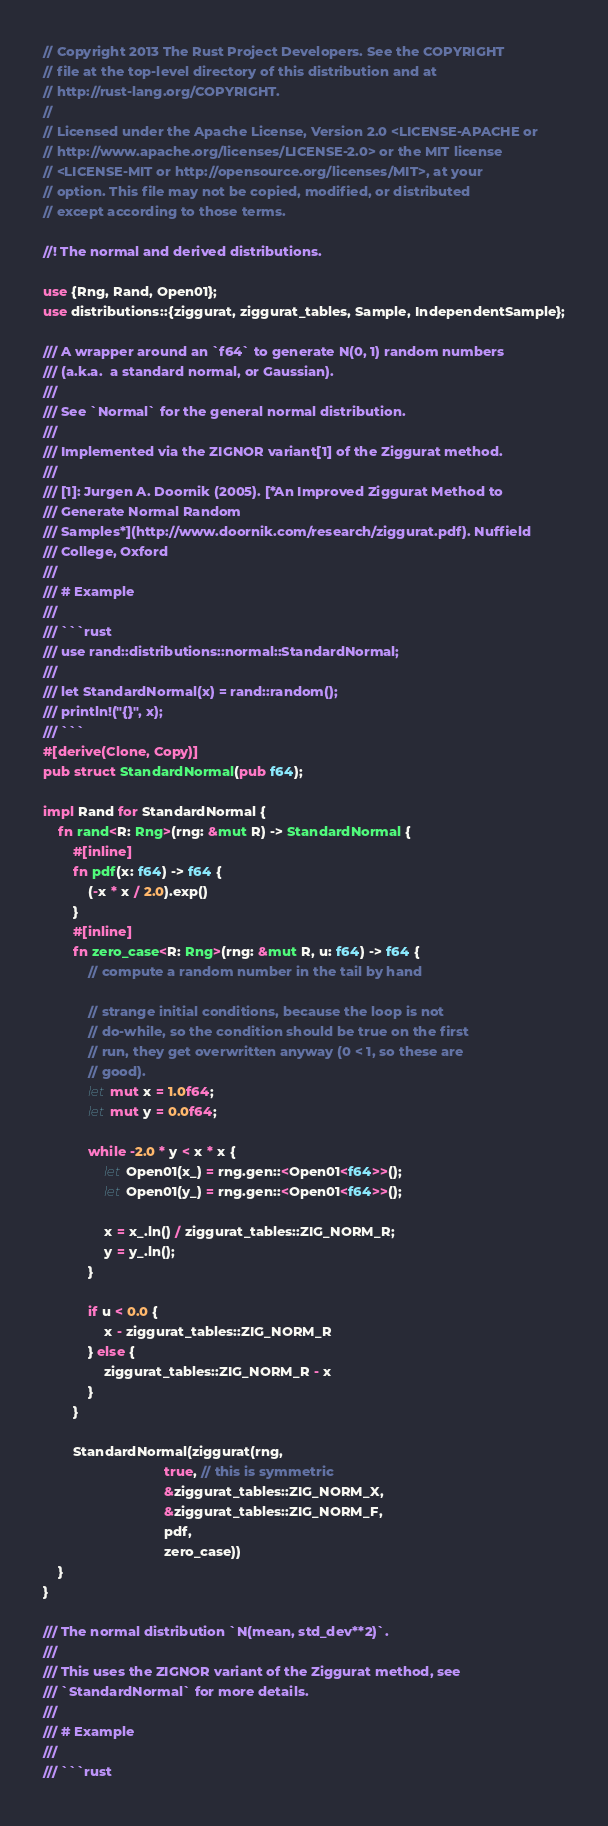<code> <loc_0><loc_0><loc_500><loc_500><_Rust_>// Copyright 2013 The Rust Project Developers. See the COPYRIGHT
// file at the top-level directory of this distribution and at
// http://rust-lang.org/COPYRIGHT.
//
// Licensed under the Apache License, Version 2.0 <LICENSE-APACHE or
// http://www.apache.org/licenses/LICENSE-2.0> or the MIT license
// <LICENSE-MIT or http://opensource.org/licenses/MIT>, at your
// option. This file may not be copied, modified, or distributed
// except according to those terms.

//! The normal and derived distributions.

use {Rng, Rand, Open01};
use distributions::{ziggurat, ziggurat_tables, Sample, IndependentSample};

/// A wrapper around an `f64` to generate N(0, 1) random numbers
/// (a.k.a.  a standard normal, or Gaussian).
///
/// See `Normal` for the general normal distribution.
///
/// Implemented via the ZIGNOR variant[1] of the Ziggurat method.
///
/// [1]: Jurgen A. Doornik (2005). [*An Improved Ziggurat Method to
/// Generate Normal Random
/// Samples*](http://www.doornik.com/research/ziggurat.pdf). Nuffield
/// College, Oxford
///
/// # Example
///
/// ```rust
/// use rand::distributions::normal::StandardNormal;
///
/// let StandardNormal(x) = rand::random();
/// println!("{}", x);
/// ```
#[derive(Clone, Copy)]
pub struct StandardNormal(pub f64);

impl Rand for StandardNormal {
    fn rand<R: Rng>(rng: &mut R) -> StandardNormal {
        #[inline]
        fn pdf(x: f64) -> f64 {
            (-x * x / 2.0).exp()
        }
        #[inline]
        fn zero_case<R: Rng>(rng: &mut R, u: f64) -> f64 {
            // compute a random number in the tail by hand

            // strange initial conditions, because the loop is not
            // do-while, so the condition should be true on the first
            // run, they get overwritten anyway (0 < 1, so these are
            // good).
            let mut x = 1.0f64;
            let mut y = 0.0f64;

            while -2.0 * y < x * x {
                let Open01(x_) = rng.gen::<Open01<f64>>();
                let Open01(y_) = rng.gen::<Open01<f64>>();

                x = x_.ln() / ziggurat_tables::ZIG_NORM_R;
                y = y_.ln();
            }

            if u < 0.0 {
                x - ziggurat_tables::ZIG_NORM_R
            } else {
                ziggurat_tables::ZIG_NORM_R - x
            }
        }

        StandardNormal(ziggurat(rng,
                                true, // this is symmetric
                                &ziggurat_tables::ZIG_NORM_X,
                                &ziggurat_tables::ZIG_NORM_F,
                                pdf,
                                zero_case))
    }
}

/// The normal distribution `N(mean, std_dev**2)`.
///
/// This uses the ZIGNOR variant of the Ziggurat method, see
/// `StandardNormal` for more details.
///
/// # Example
///
/// ```rust</code> 